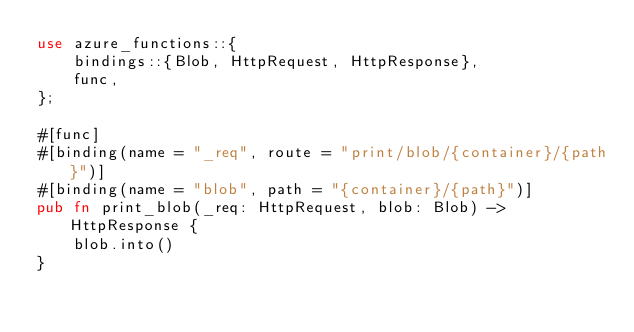<code> <loc_0><loc_0><loc_500><loc_500><_Rust_>use azure_functions::{
    bindings::{Blob, HttpRequest, HttpResponse},
    func,
};

#[func]
#[binding(name = "_req", route = "print/blob/{container}/{path}")]
#[binding(name = "blob", path = "{container}/{path}")]
pub fn print_blob(_req: HttpRequest, blob: Blob) -> HttpResponse {
    blob.into()
}
</code> 